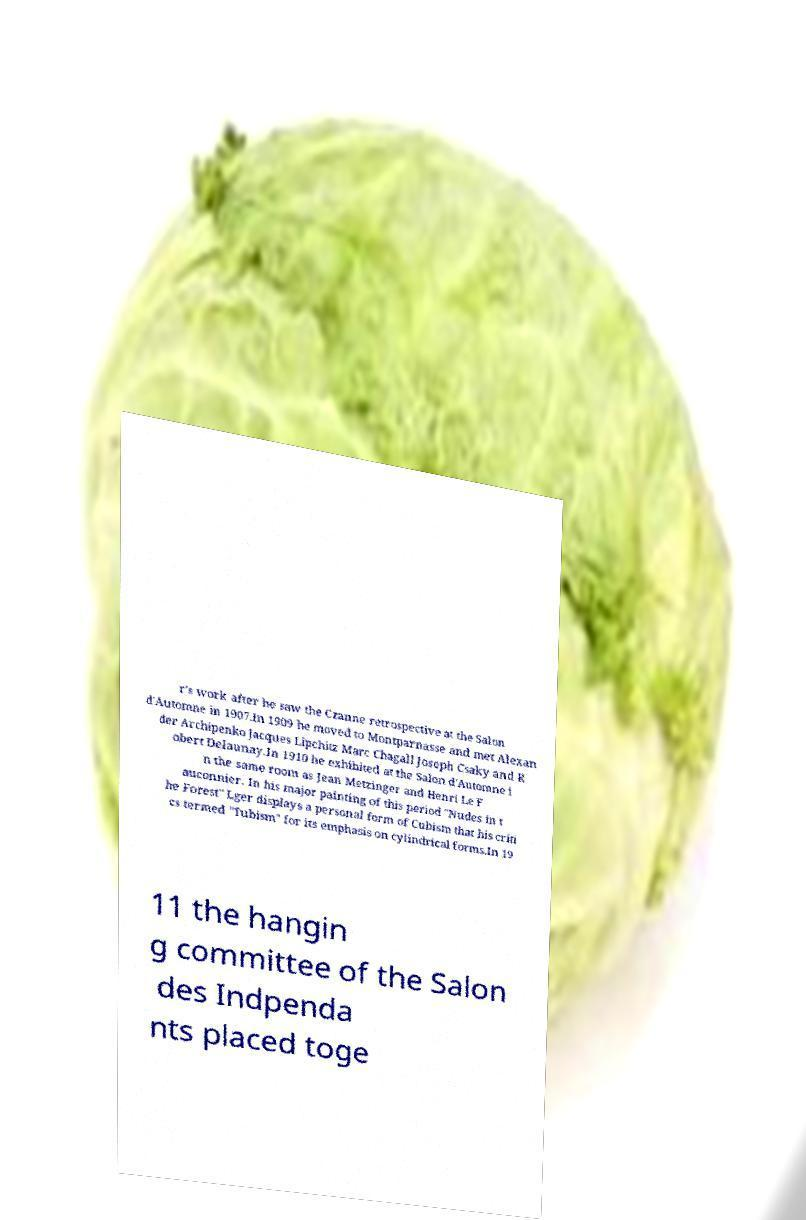Can you accurately transcribe the text from the provided image for me? r's work after he saw the Czanne retrospective at the Salon d'Automne in 1907.In 1909 he moved to Montparnasse and met Alexan der Archipenko Jacques Lipchitz Marc Chagall Joseph Csaky and R obert Delaunay.In 1910 he exhibited at the Salon d'Automne i n the same room as Jean Metzinger and Henri Le F auconnier. In his major painting of this period "Nudes in t he Forest" Lger displays a personal form of Cubism that his criti cs termed "Tubism" for its emphasis on cylindrical forms.In 19 11 the hangin g committee of the Salon des Indpenda nts placed toge 